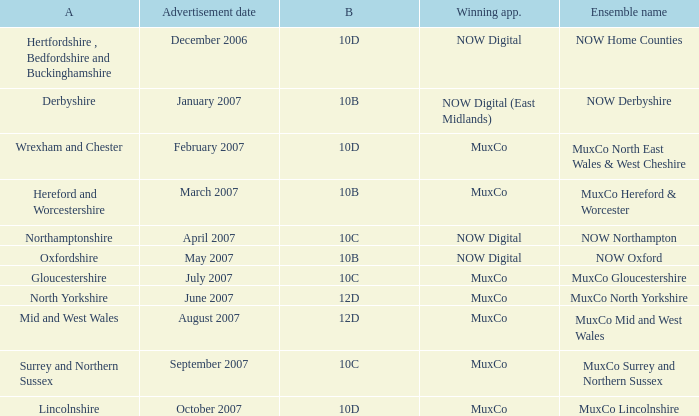Who is the Winning Applicant of Block 10B in Derbyshire Area? NOW Digital (East Midlands). 